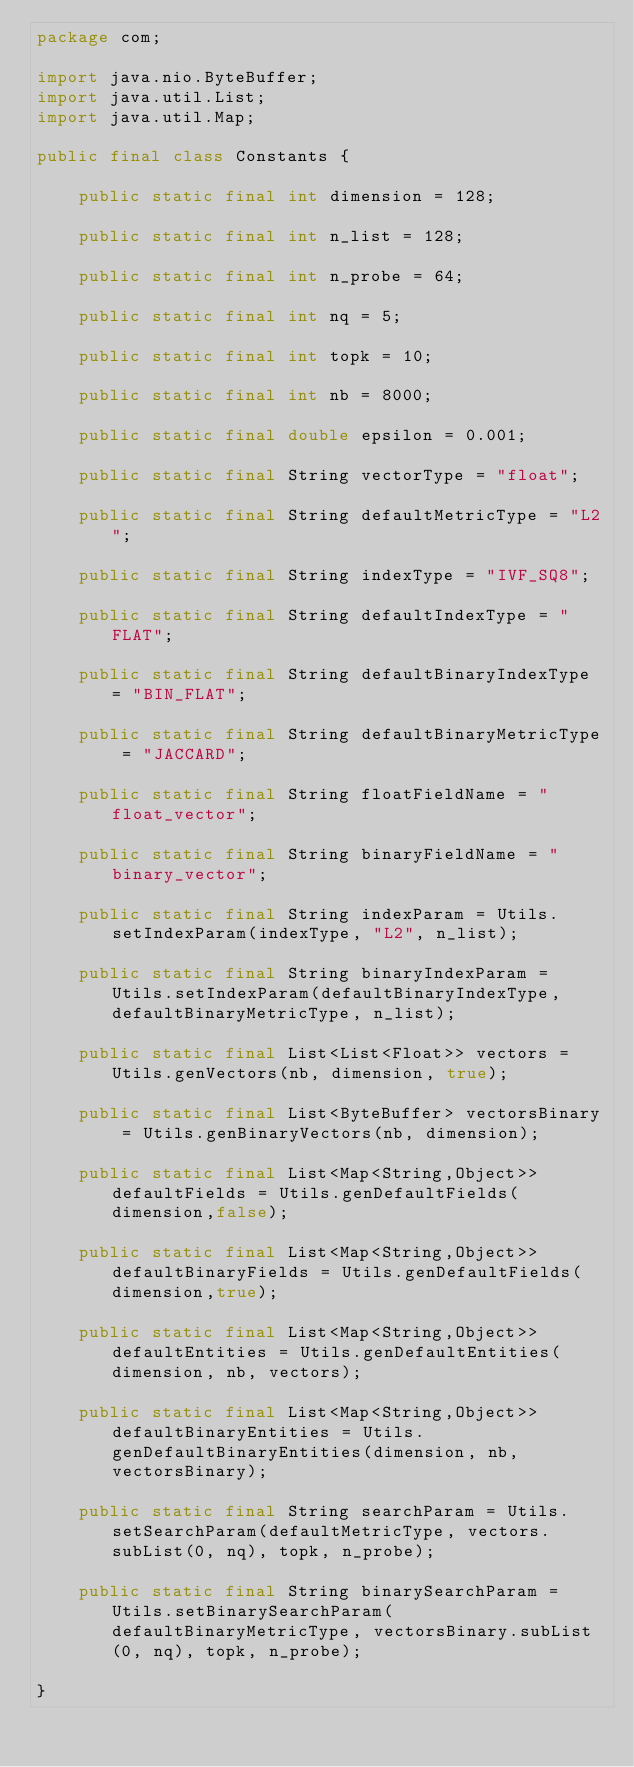Convert code to text. <code><loc_0><loc_0><loc_500><loc_500><_Java_>package com;

import java.nio.ByteBuffer;
import java.util.List;
import java.util.Map;

public final class Constants {

    public static final int dimension = 128;

    public static final int n_list = 128;

    public static final int n_probe = 64;

    public static final int nq = 5;

    public static final int topk = 10;

    public static final int nb = 8000;

    public static final double epsilon = 0.001;

    public static final String vectorType = "float";

    public static final String defaultMetricType = "L2";

    public static final String indexType = "IVF_SQ8";

    public static final String defaultIndexType = "FLAT";

    public static final String defaultBinaryIndexType = "BIN_FLAT";

    public static final String defaultBinaryMetricType = "JACCARD";

    public static final String floatFieldName = "float_vector";

    public static final String binaryFieldName = "binary_vector";

    public static final String indexParam = Utils.setIndexParam(indexType, "L2", n_list);

    public static final String binaryIndexParam = Utils.setIndexParam(defaultBinaryIndexType, defaultBinaryMetricType, n_list);

    public static final List<List<Float>> vectors = Utils.genVectors(nb, dimension, true);

    public static final List<ByteBuffer> vectorsBinary = Utils.genBinaryVectors(nb, dimension);

    public static final List<Map<String,Object>> defaultFields = Utils.genDefaultFields(dimension,false);

    public static final List<Map<String,Object>> defaultBinaryFields = Utils.genDefaultFields(dimension,true);

    public static final List<Map<String,Object>> defaultEntities = Utils.genDefaultEntities(dimension, nb, vectors);

    public static final List<Map<String,Object>> defaultBinaryEntities = Utils.genDefaultBinaryEntities(dimension, nb, vectorsBinary);

    public static final String searchParam = Utils.setSearchParam(defaultMetricType, vectors.subList(0, nq), topk, n_probe);

    public static final String binarySearchParam = Utils.setBinarySearchParam(defaultBinaryMetricType, vectorsBinary.subList(0, nq), topk, n_probe);

}
</code> 